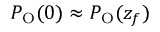<formula> <loc_0><loc_0><loc_500><loc_500>P _ { O } ( 0 ) \approx P _ { O } ( z _ { f } )</formula> 